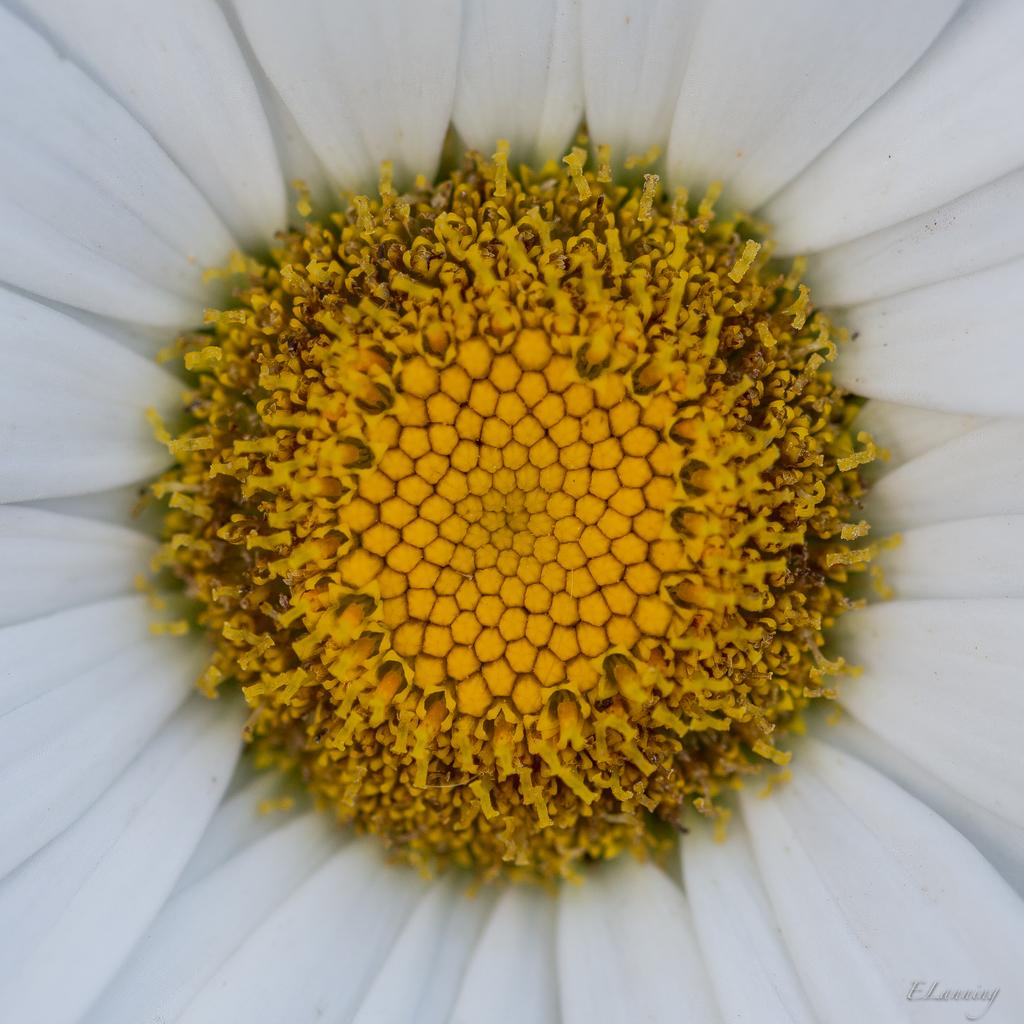What type of flower is in the image? There is a white flower in the image. Are there any other colors visible on the flower? Yes, there are yellow buds on the flower. What type of stocking is the government wearing in the image? There is no government or stocking present in the image; it only features a white flower with yellow buds. 